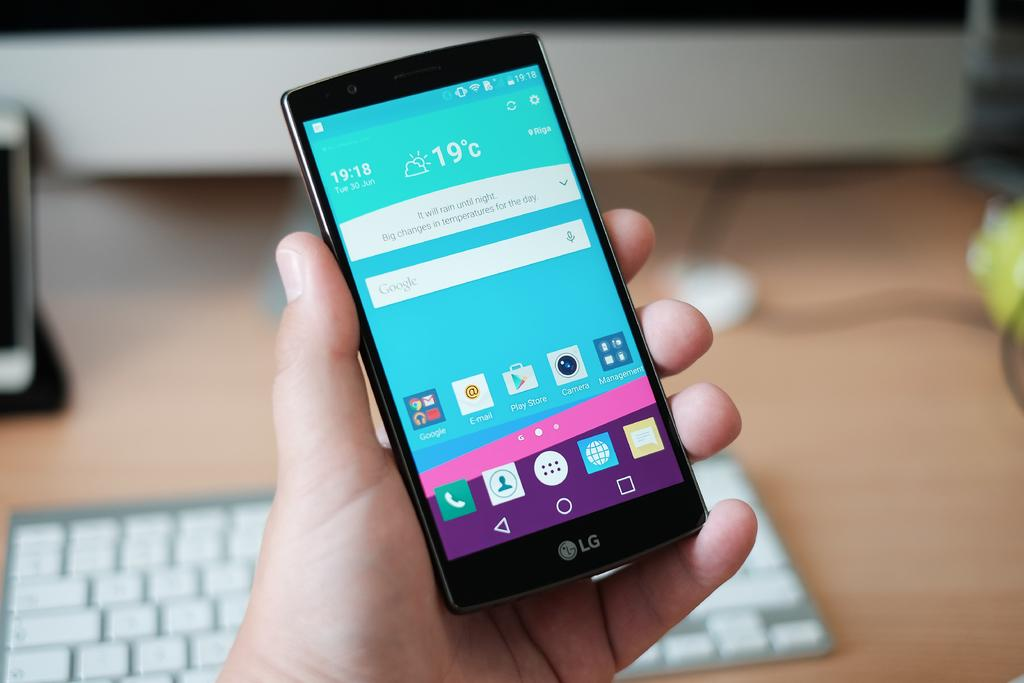<image>
Relay a brief, clear account of the picture shown. Cellphone showing the current time is at 19:18 and the temperature is 19 celcius. 